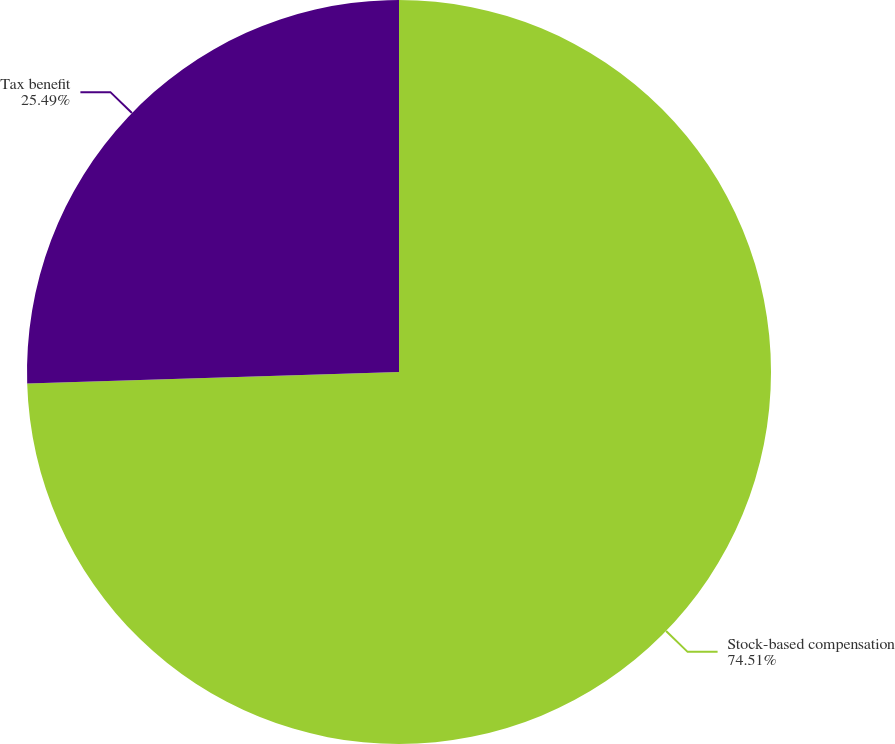Convert chart. <chart><loc_0><loc_0><loc_500><loc_500><pie_chart><fcel>Stock-based compensation<fcel>Tax benefit<nl><fcel>74.51%<fcel>25.49%<nl></chart> 